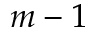Convert formula to latex. <formula><loc_0><loc_0><loc_500><loc_500>m - 1</formula> 